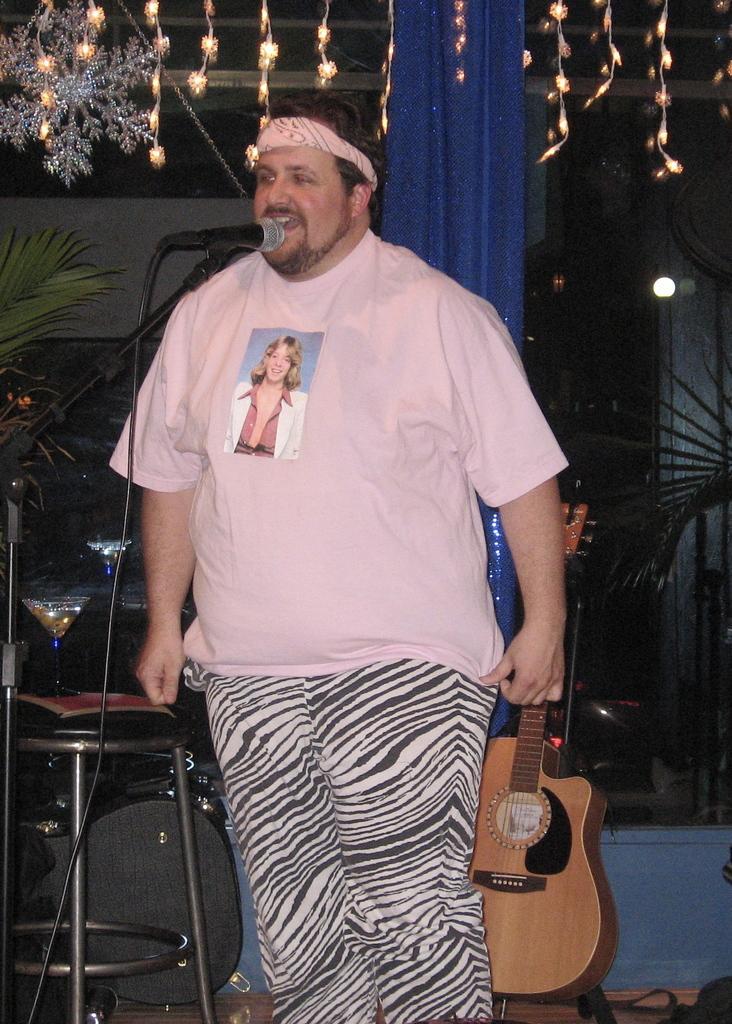How would you summarize this image in a sentence or two? In this image I see a man who is standing in front of a mic and In the background I see a guitar, a stool, few plants and the lights. 